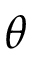Convert formula to latex. <formula><loc_0><loc_0><loc_500><loc_500>\theta</formula> 